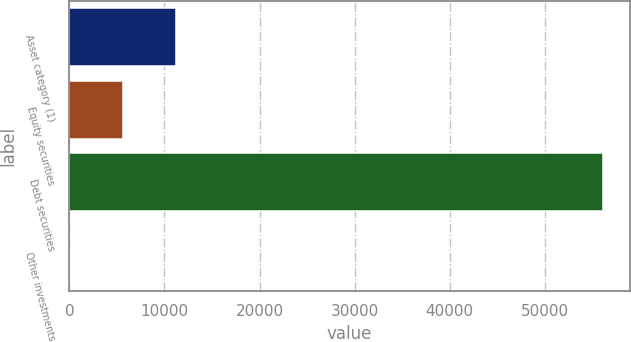Convert chart. <chart><loc_0><loc_0><loc_500><loc_500><bar_chart><fcel>Asset category (1)<fcel>Equity securities<fcel>Debt securities<fcel>Other investments<nl><fcel>11222.4<fcel>5612.7<fcel>56100<fcel>3<nl></chart> 